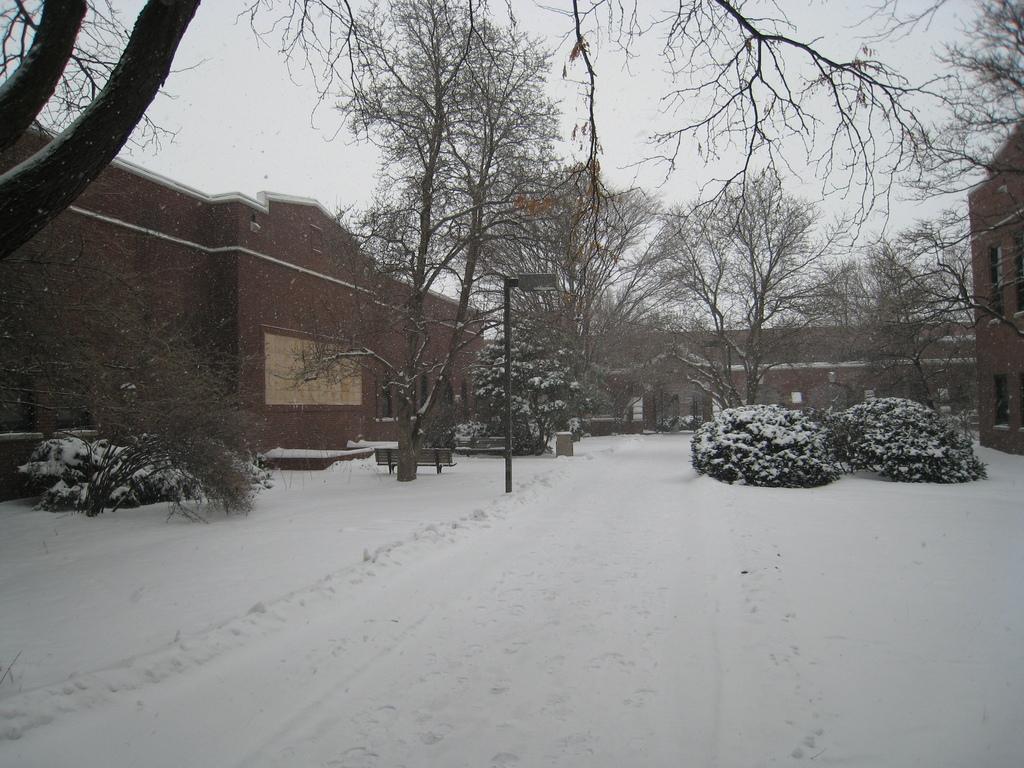Describe this image in one or two sentences. In the foreground of this image, on the bottom, there is a snow. In the background, there are trees, a pole, shrubs and few buildings. On the top, there is the sky and the trees. 